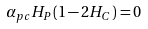<formula> <loc_0><loc_0><loc_500><loc_500>\alpha _ { p c } H _ { P } ( 1 - 2 H _ { C } ) = 0</formula> 